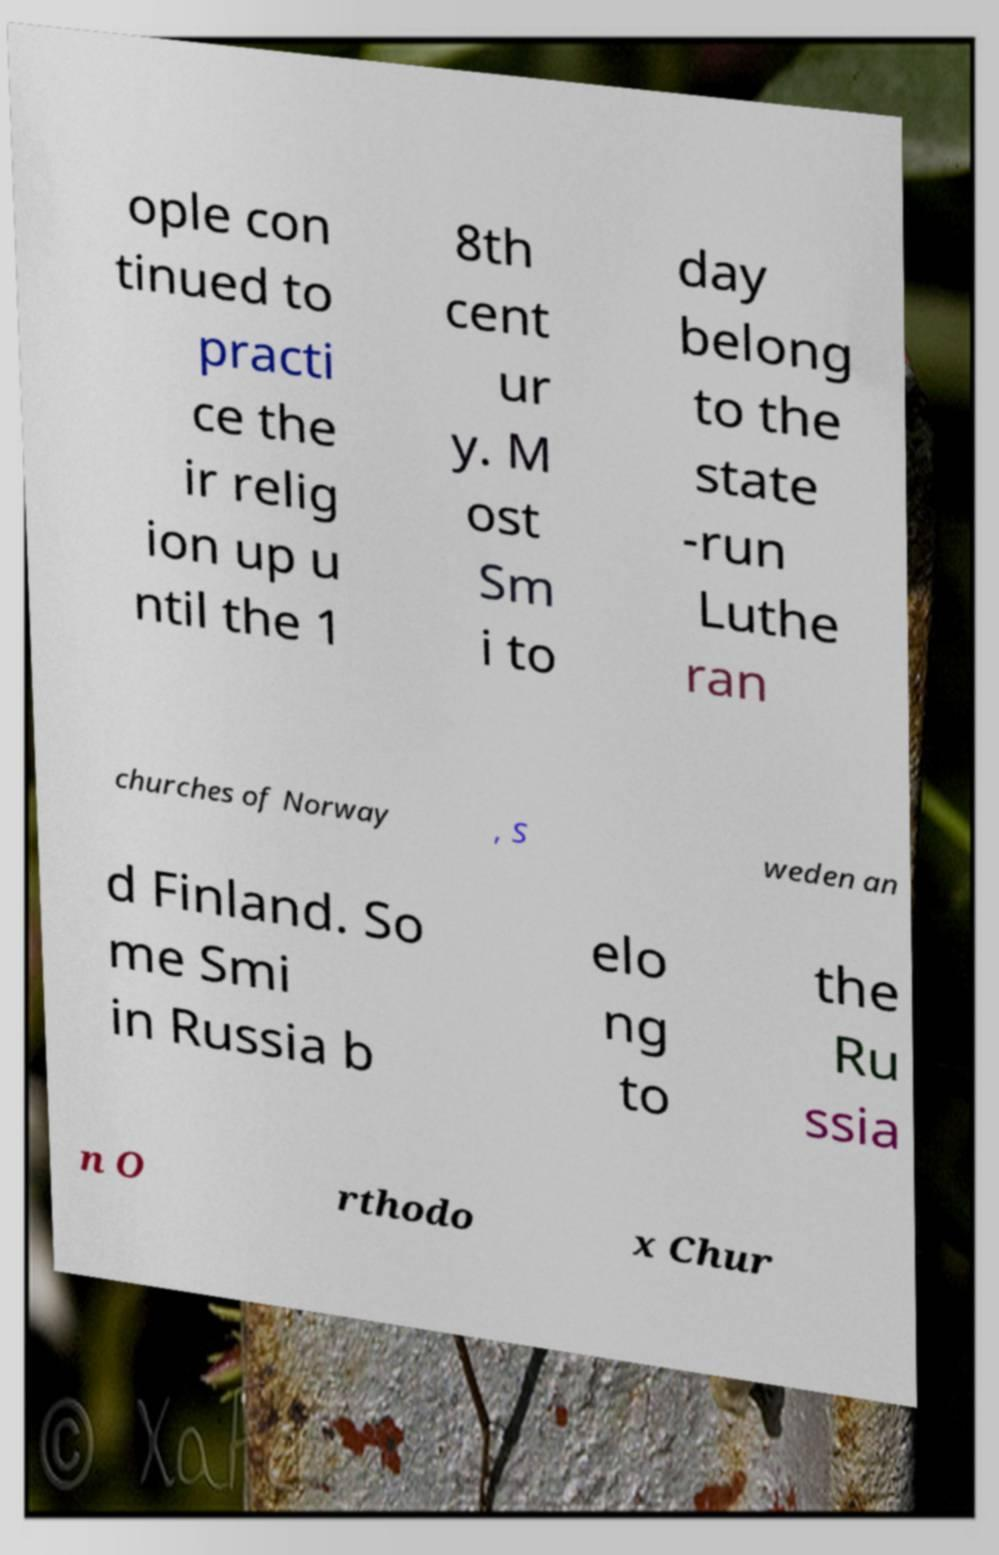I need the written content from this picture converted into text. Can you do that? ople con tinued to practi ce the ir relig ion up u ntil the 1 8th cent ur y. M ost Sm i to day belong to the state -run Luthe ran churches of Norway , S weden an d Finland. So me Smi in Russia b elo ng to the Ru ssia n O rthodo x Chur 